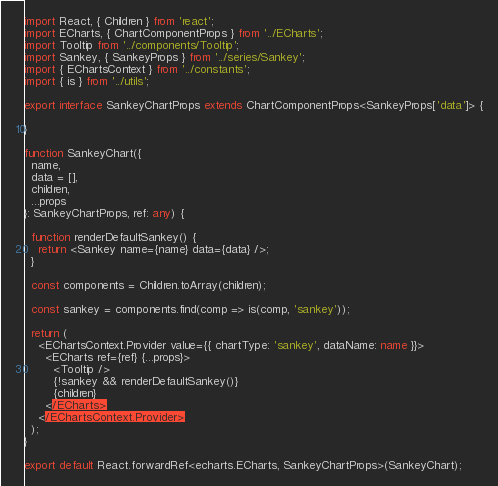Convert code to text. <code><loc_0><loc_0><loc_500><loc_500><_TypeScript_>import React, { Children } from 'react';
import ECharts, { ChartComponentProps } from '../ECharts';
import Tooltip from '../components/Tooltip';
import Sankey, { SankeyProps } from '../series/Sankey';
import { EChartsContext } from '../constants';
import { is } from '../utils';

export interface SankeyChartProps extends ChartComponentProps<SankeyProps['data']> {

}

function SankeyChart({
  name,
  data = [],
  children,
  ...props
}: SankeyChartProps, ref: any) {

  function renderDefaultSankey() {
    return <Sankey name={name} data={data} />;
  }

  const components = Children.toArray(children);

  const sankey = components.find(comp => is(comp, 'sankey'));

  return (
    <EChartsContext.Provider value={{ chartType: 'sankey', dataName: name }}>
      <ECharts ref={ref} {...props}>
        <Tooltip />
        {!sankey && renderDefaultSankey()}
        {children}
      </ECharts>
    </EChartsContext.Provider>
  );
}

export default React.forwardRef<echarts.ECharts, SankeyChartProps>(SankeyChart);
</code> 